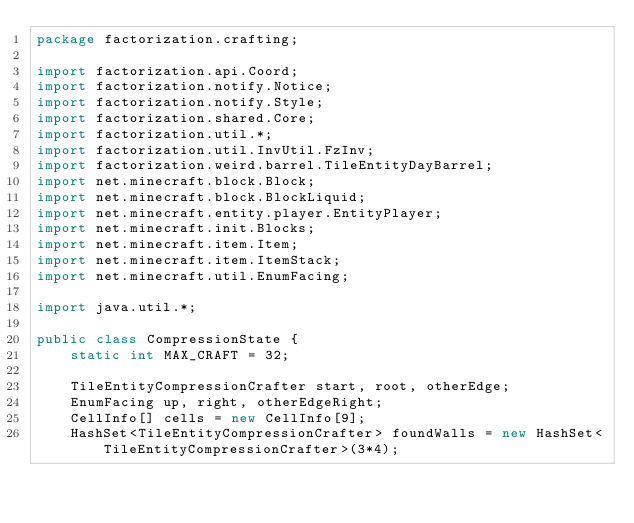<code> <loc_0><loc_0><loc_500><loc_500><_Java_>package factorization.crafting;

import factorization.api.Coord;
import factorization.notify.Notice;
import factorization.notify.Style;
import factorization.shared.Core;
import factorization.util.*;
import factorization.util.InvUtil.FzInv;
import factorization.weird.barrel.TileEntityDayBarrel;
import net.minecraft.block.Block;
import net.minecraft.block.BlockLiquid;
import net.minecraft.entity.player.EntityPlayer;
import net.minecraft.init.Blocks;
import net.minecraft.item.Item;
import net.minecraft.item.ItemStack;
import net.minecraft.util.EnumFacing;

import java.util.*;

public class CompressionState {
    static int MAX_CRAFT = 32;
    
    TileEntityCompressionCrafter start, root, otherEdge;
    EnumFacing up, right, otherEdgeRight;
    CellInfo[] cells = new CellInfo[9];
    HashSet<TileEntityCompressionCrafter> foundWalls = new HashSet<TileEntityCompressionCrafter>(3*4);</code> 